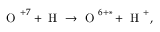<formula> <loc_0><loc_0><loc_500><loc_500>O ^ { + 7 } + H \rightarrow O ^ { 6 + * } + H ^ { + } ,</formula> 